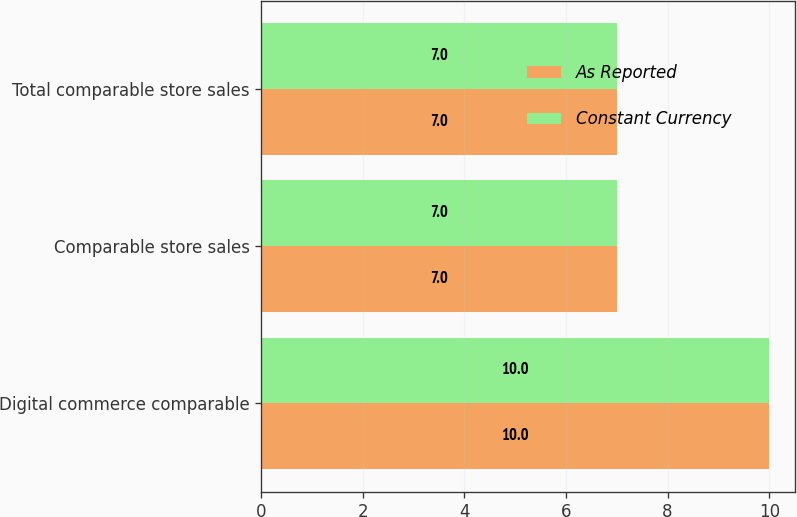Convert chart. <chart><loc_0><loc_0><loc_500><loc_500><stacked_bar_chart><ecel><fcel>Digital commerce comparable<fcel>Comparable store sales<fcel>Total comparable store sales<nl><fcel>As Reported<fcel>10<fcel>7<fcel>7<nl><fcel>Constant Currency<fcel>10<fcel>7<fcel>7<nl></chart> 